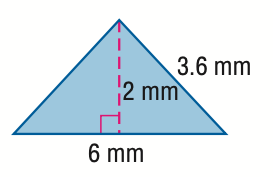Answer the mathemtical geometry problem and directly provide the correct option letter.
Question: Find the area of the triangle. Round to the nearest tenth if necessary.
Choices: A: 6 B: 12 C: 13.2 D: 24 A 